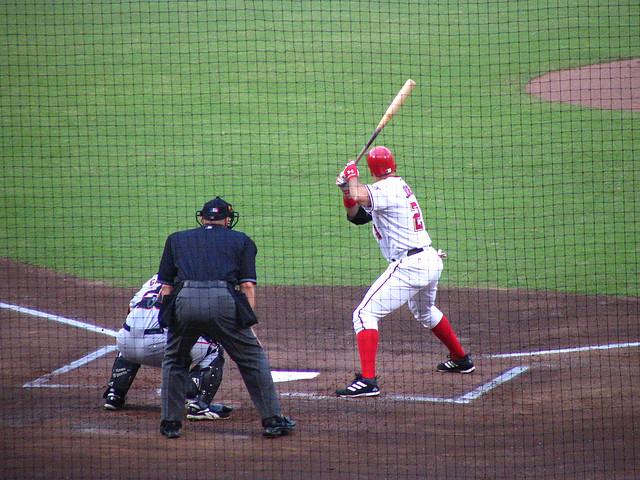Is anyone not at home plate visible?
Answer briefly. No. How many people?
Keep it brief. 3. What color are the batter's socks?
Keep it brief. Red. 